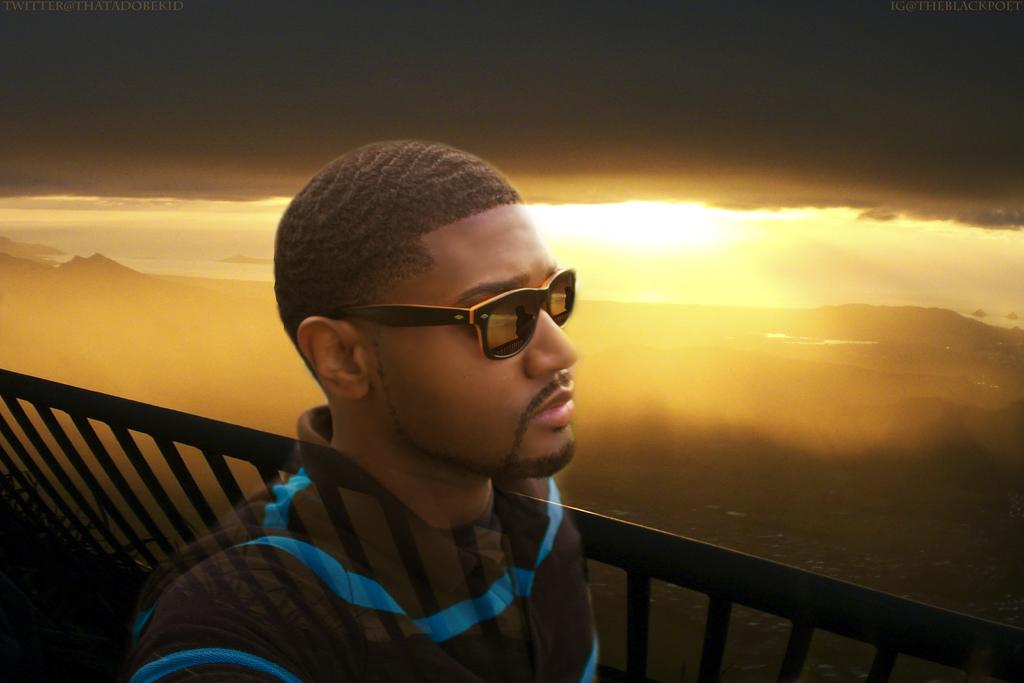What type of image is being described? The image is animated. Can you describe the person in the image? There is a person wearing spectacles in the image. What is the background of the image? There is a fence and the sky is visible in the image. What can be seen in the sky? Clouds are present in the sky. How many chairs are visible in the image? There are no chairs present in the image. What year is depicted in the image? The image does not depict a specific year. 